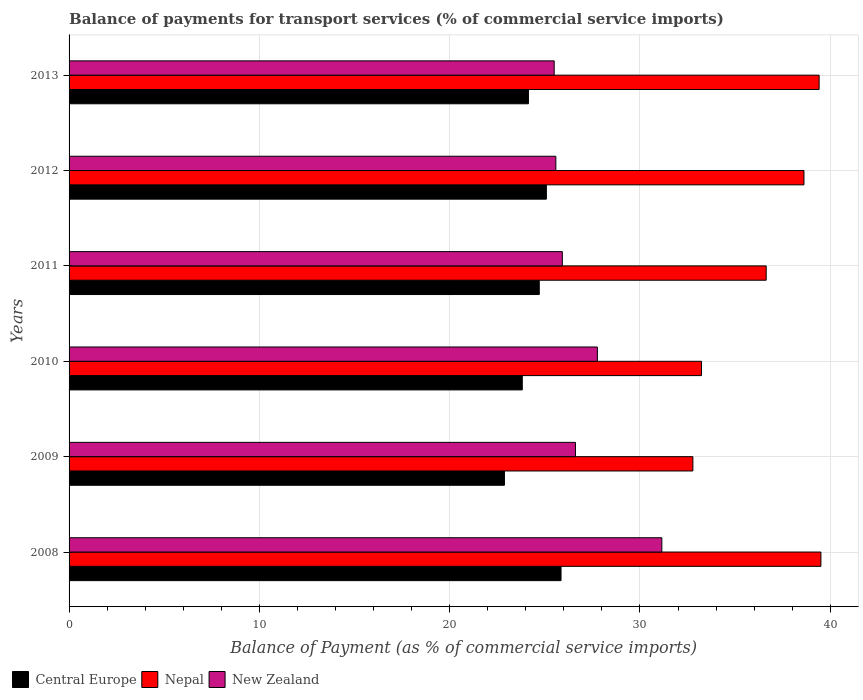How many different coloured bars are there?
Your response must be concise. 3. How many groups of bars are there?
Ensure brevity in your answer.  6. Are the number of bars on each tick of the Y-axis equal?
Keep it short and to the point. Yes. How many bars are there on the 6th tick from the bottom?
Offer a terse response. 3. What is the label of the 3rd group of bars from the top?
Keep it short and to the point. 2011. What is the balance of payments for transport services in Nepal in 2010?
Keep it short and to the point. 33.23. Across all years, what is the maximum balance of payments for transport services in Central Europe?
Your response must be concise. 25.85. Across all years, what is the minimum balance of payments for transport services in New Zealand?
Your answer should be very brief. 25.49. What is the total balance of payments for transport services in Central Europe in the graph?
Ensure brevity in your answer.  146.47. What is the difference between the balance of payments for transport services in Nepal in 2008 and that in 2011?
Provide a short and direct response. 2.88. What is the difference between the balance of payments for transport services in Central Europe in 2010 and the balance of payments for transport services in New Zealand in 2012?
Your answer should be compact. -1.76. What is the average balance of payments for transport services in Nepal per year?
Your answer should be very brief. 36.7. In the year 2013, what is the difference between the balance of payments for transport services in Central Europe and balance of payments for transport services in New Zealand?
Provide a succinct answer. -1.35. What is the ratio of the balance of payments for transport services in Central Europe in 2010 to that in 2012?
Your answer should be compact. 0.95. Is the balance of payments for transport services in New Zealand in 2008 less than that in 2012?
Your answer should be compact. No. What is the difference between the highest and the second highest balance of payments for transport services in Nepal?
Keep it short and to the point. 0.09. What is the difference between the highest and the lowest balance of payments for transport services in Central Europe?
Make the answer very short. 2.97. Is the sum of the balance of payments for transport services in Nepal in 2010 and 2011 greater than the maximum balance of payments for transport services in Central Europe across all years?
Your response must be concise. Yes. What does the 3rd bar from the top in 2011 represents?
Keep it short and to the point. Central Europe. What does the 1st bar from the bottom in 2012 represents?
Provide a short and direct response. Central Europe. How many bars are there?
Give a very brief answer. 18. Are the values on the major ticks of X-axis written in scientific E-notation?
Offer a terse response. No. Does the graph contain grids?
Keep it short and to the point. Yes. Where does the legend appear in the graph?
Provide a short and direct response. Bottom left. How are the legend labels stacked?
Keep it short and to the point. Horizontal. What is the title of the graph?
Your response must be concise. Balance of payments for transport services (% of commercial service imports). Does "Belgium" appear as one of the legend labels in the graph?
Offer a terse response. No. What is the label or title of the X-axis?
Your answer should be compact. Balance of Payment (as % of commercial service imports). What is the label or title of the Y-axis?
Keep it short and to the point. Years. What is the Balance of Payment (as % of commercial service imports) in Central Europe in 2008?
Your answer should be compact. 25.85. What is the Balance of Payment (as % of commercial service imports) of Nepal in 2008?
Provide a succinct answer. 39.51. What is the Balance of Payment (as % of commercial service imports) of New Zealand in 2008?
Give a very brief answer. 31.15. What is the Balance of Payment (as % of commercial service imports) in Central Europe in 2009?
Provide a short and direct response. 22.88. What is the Balance of Payment (as % of commercial service imports) in Nepal in 2009?
Provide a short and direct response. 32.78. What is the Balance of Payment (as % of commercial service imports) in New Zealand in 2009?
Ensure brevity in your answer.  26.61. What is the Balance of Payment (as % of commercial service imports) in Central Europe in 2010?
Provide a succinct answer. 23.82. What is the Balance of Payment (as % of commercial service imports) of Nepal in 2010?
Make the answer very short. 33.23. What is the Balance of Payment (as % of commercial service imports) in New Zealand in 2010?
Your response must be concise. 27.76. What is the Balance of Payment (as % of commercial service imports) in Central Europe in 2011?
Give a very brief answer. 24.71. What is the Balance of Payment (as % of commercial service imports) in Nepal in 2011?
Your answer should be very brief. 36.63. What is the Balance of Payment (as % of commercial service imports) of New Zealand in 2011?
Keep it short and to the point. 25.92. What is the Balance of Payment (as % of commercial service imports) of Central Europe in 2012?
Make the answer very short. 25.08. What is the Balance of Payment (as % of commercial service imports) in Nepal in 2012?
Offer a terse response. 38.62. What is the Balance of Payment (as % of commercial service imports) in New Zealand in 2012?
Provide a succinct answer. 25.58. What is the Balance of Payment (as % of commercial service imports) of Central Europe in 2013?
Offer a very short reply. 24.14. What is the Balance of Payment (as % of commercial service imports) in Nepal in 2013?
Provide a succinct answer. 39.41. What is the Balance of Payment (as % of commercial service imports) in New Zealand in 2013?
Make the answer very short. 25.49. Across all years, what is the maximum Balance of Payment (as % of commercial service imports) in Central Europe?
Your answer should be compact. 25.85. Across all years, what is the maximum Balance of Payment (as % of commercial service imports) in Nepal?
Your answer should be very brief. 39.51. Across all years, what is the maximum Balance of Payment (as % of commercial service imports) in New Zealand?
Provide a short and direct response. 31.15. Across all years, what is the minimum Balance of Payment (as % of commercial service imports) in Central Europe?
Make the answer very short. 22.88. Across all years, what is the minimum Balance of Payment (as % of commercial service imports) in Nepal?
Offer a terse response. 32.78. Across all years, what is the minimum Balance of Payment (as % of commercial service imports) of New Zealand?
Give a very brief answer. 25.49. What is the total Balance of Payment (as % of commercial service imports) in Central Europe in the graph?
Offer a very short reply. 146.47. What is the total Balance of Payment (as % of commercial service imports) in Nepal in the graph?
Provide a short and direct response. 220.18. What is the total Balance of Payment (as % of commercial service imports) in New Zealand in the graph?
Offer a very short reply. 162.51. What is the difference between the Balance of Payment (as % of commercial service imports) of Central Europe in 2008 and that in 2009?
Keep it short and to the point. 2.97. What is the difference between the Balance of Payment (as % of commercial service imports) of Nepal in 2008 and that in 2009?
Provide a succinct answer. 6.73. What is the difference between the Balance of Payment (as % of commercial service imports) in New Zealand in 2008 and that in 2009?
Keep it short and to the point. 4.54. What is the difference between the Balance of Payment (as % of commercial service imports) of Central Europe in 2008 and that in 2010?
Ensure brevity in your answer.  2.04. What is the difference between the Balance of Payment (as % of commercial service imports) in Nepal in 2008 and that in 2010?
Keep it short and to the point. 6.28. What is the difference between the Balance of Payment (as % of commercial service imports) of New Zealand in 2008 and that in 2010?
Make the answer very short. 3.39. What is the difference between the Balance of Payment (as % of commercial service imports) of Central Europe in 2008 and that in 2011?
Offer a terse response. 1.14. What is the difference between the Balance of Payment (as % of commercial service imports) in Nepal in 2008 and that in 2011?
Provide a short and direct response. 2.88. What is the difference between the Balance of Payment (as % of commercial service imports) in New Zealand in 2008 and that in 2011?
Provide a succinct answer. 5.23. What is the difference between the Balance of Payment (as % of commercial service imports) of Central Europe in 2008 and that in 2012?
Offer a terse response. 0.77. What is the difference between the Balance of Payment (as % of commercial service imports) in Nepal in 2008 and that in 2012?
Provide a short and direct response. 0.89. What is the difference between the Balance of Payment (as % of commercial service imports) of New Zealand in 2008 and that in 2012?
Your response must be concise. 5.57. What is the difference between the Balance of Payment (as % of commercial service imports) in Central Europe in 2008 and that in 2013?
Offer a very short reply. 1.71. What is the difference between the Balance of Payment (as % of commercial service imports) in Nepal in 2008 and that in 2013?
Give a very brief answer. 0.09. What is the difference between the Balance of Payment (as % of commercial service imports) of New Zealand in 2008 and that in 2013?
Offer a terse response. 5.66. What is the difference between the Balance of Payment (as % of commercial service imports) in Central Europe in 2009 and that in 2010?
Your answer should be compact. -0.94. What is the difference between the Balance of Payment (as % of commercial service imports) in Nepal in 2009 and that in 2010?
Keep it short and to the point. -0.45. What is the difference between the Balance of Payment (as % of commercial service imports) of New Zealand in 2009 and that in 2010?
Offer a very short reply. -1.15. What is the difference between the Balance of Payment (as % of commercial service imports) in Central Europe in 2009 and that in 2011?
Provide a succinct answer. -1.83. What is the difference between the Balance of Payment (as % of commercial service imports) in Nepal in 2009 and that in 2011?
Your response must be concise. -3.85. What is the difference between the Balance of Payment (as % of commercial service imports) of New Zealand in 2009 and that in 2011?
Keep it short and to the point. 0.69. What is the difference between the Balance of Payment (as % of commercial service imports) of Central Europe in 2009 and that in 2012?
Provide a succinct answer. -2.2. What is the difference between the Balance of Payment (as % of commercial service imports) in Nepal in 2009 and that in 2012?
Give a very brief answer. -5.84. What is the difference between the Balance of Payment (as % of commercial service imports) of New Zealand in 2009 and that in 2012?
Ensure brevity in your answer.  1.03. What is the difference between the Balance of Payment (as % of commercial service imports) of Central Europe in 2009 and that in 2013?
Provide a short and direct response. -1.26. What is the difference between the Balance of Payment (as % of commercial service imports) of Nepal in 2009 and that in 2013?
Keep it short and to the point. -6.63. What is the difference between the Balance of Payment (as % of commercial service imports) in New Zealand in 2009 and that in 2013?
Your response must be concise. 1.12. What is the difference between the Balance of Payment (as % of commercial service imports) of Central Europe in 2010 and that in 2011?
Offer a very short reply. -0.89. What is the difference between the Balance of Payment (as % of commercial service imports) of Nepal in 2010 and that in 2011?
Make the answer very short. -3.4. What is the difference between the Balance of Payment (as % of commercial service imports) of New Zealand in 2010 and that in 2011?
Your answer should be compact. 1.84. What is the difference between the Balance of Payment (as % of commercial service imports) in Central Europe in 2010 and that in 2012?
Your answer should be very brief. -1.27. What is the difference between the Balance of Payment (as % of commercial service imports) in Nepal in 2010 and that in 2012?
Keep it short and to the point. -5.39. What is the difference between the Balance of Payment (as % of commercial service imports) in New Zealand in 2010 and that in 2012?
Give a very brief answer. 2.18. What is the difference between the Balance of Payment (as % of commercial service imports) in Central Europe in 2010 and that in 2013?
Your answer should be compact. -0.32. What is the difference between the Balance of Payment (as % of commercial service imports) of Nepal in 2010 and that in 2013?
Give a very brief answer. -6.18. What is the difference between the Balance of Payment (as % of commercial service imports) in New Zealand in 2010 and that in 2013?
Keep it short and to the point. 2.27. What is the difference between the Balance of Payment (as % of commercial service imports) of Central Europe in 2011 and that in 2012?
Provide a succinct answer. -0.37. What is the difference between the Balance of Payment (as % of commercial service imports) of Nepal in 2011 and that in 2012?
Ensure brevity in your answer.  -1.99. What is the difference between the Balance of Payment (as % of commercial service imports) in New Zealand in 2011 and that in 2012?
Provide a succinct answer. 0.34. What is the difference between the Balance of Payment (as % of commercial service imports) in Central Europe in 2011 and that in 2013?
Provide a succinct answer. 0.57. What is the difference between the Balance of Payment (as % of commercial service imports) of Nepal in 2011 and that in 2013?
Provide a short and direct response. -2.78. What is the difference between the Balance of Payment (as % of commercial service imports) of New Zealand in 2011 and that in 2013?
Make the answer very short. 0.43. What is the difference between the Balance of Payment (as % of commercial service imports) in Central Europe in 2012 and that in 2013?
Make the answer very short. 0.94. What is the difference between the Balance of Payment (as % of commercial service imports) of Nepal in 2012 and that in 2013?
Your answer should be compact. -0.8. What is the difference between the Balance of Payment (as % of commercial service imports) in New Zealand in 2012 and that in 2013?
Give a very brief answer. 0.09. What is the difference between the Balance of Payment (as % of commercial service imports) in Central Europe in 2008 and the Balance of Payment (as % of commercial service imports) in Nepal in 2009?
Ensure brevity in your answer.  -6.93. What is the difference between the Balance of Payment (as % of commercial service imports) of Central Europe in 2008 and the Balance of Payment (as % of commercial service imports) of New Zealand in 2009?
Offer a terse response. -0.76. What is the difference between the Balance of Payment (as % of commercial service imports) of Nepal in 2008 and the Balance of Payment (as % of commercial service imports) of New Zealand in 2009?
Offer a very short reply. 12.9. What is the difference between the Balance of Payment (as % of commercial service imports) of Central Europe in 2008 and the Balance of Payment (as % of commercial service imports) of Nepal in 2010?
Your response must be concise. -7.38. What is the difference between the Balance of Payment (as % of commercial service imports) of Central Europe in 2008 and the Balance of Payment (as % of commercial service imports) of New Zealand in 2010?
Keep it short and to the point. -1.91. What is the difference between the Balance of Payment (as % of commercial service imports) in Nepal in 2008 and the Balance of Payment (as % of commercial service imports) in New Zealand in 2010?
Keep it short and to the point. 11.75. What is the difference between the Balance of Payment (as % of commercial service imports) in Central Europe in 2008 and the Balance of Payment (as % of commercial service imports) in Nepal in 2011?
Ensure brevity in your answer.  -10.78. What is the difference between the Balance of Payment (as % of commercial service imports) in Central Europe in 2008 and the Balance of Payment (as % of commercial service imports) in New Zealand in 2011?
Your response must be concise. -0.07. What is the difference between the Balance of Payment (as % of commercial service imports) of Nepal in 2008 and the Balance of Payment (as % of commercial service imports) of New Zealand in 2011?
Your answer should be compact. 13.59. What is the difference between the Balance of Payment (as % of commercial service imports) of Central Europe in 2008 and the Balance of Payment (as % of commercial service imports) of Nepal in 2012?
Your answer should be very brief. -12.77. What is the difference between the Balance of Payment (as % of commercial service imports) of Central Europe in 2008 and the Balance of Payment (as % of commercial service imports) of New Zealand in 2012?
Offer a very short reply. 0.27. What is the difference between the Balance of Payment (as % of commercial service imports) in Nepal in 2008 and the Balance of Payment (as % of commercial service imports) in New Zealand in 2012?
Give a very brief answer. 13.93. What is the difference between the Balance of Payment (as % of commercial service imports) of Central Europe in 2008 and the Balance of Payment (as % of commercial service imports) of Nepal in 2013?
Your response must be concise. -13.56. What is the difference between the Balance of Payment (as % of commercial service imports) in Central Europe in 2008 and the Balance of Payment (as % of commercial service imports) in New Zealand in 2013?
Offer a very short reply. 0.36. What is the difference between the Balance of Payment (as % of commercial service imports) of Nepal in 2008 and the Balance of Payment (as % of commercial service imports) of New Zealand in 2013?
Give a very brief answer. 14.01. What is the difference between the Balance of Payment (as % of commercial service imports) in Central Europe in 2009 and the Balance of Payment (as % of commercial service imports) in Nepal in 2010?
Make the answer very short. -10.35. What is the difference between the Balance of Payment (as % of commercial service imports) of Central Europe in 2009 and the Balance of Payment (as % of commercial service imports) of New Zealand in 2010?
Make the answer very short. -4.88. What is the difference between the Balance of Payment (as % of commercial service imports) in Nepal in 2009 and the Balance of Payment (as % of commercial service imports) in New Zealand in 2010?
Your response must be concise. 5.02. What is the difference between the Balance of Payment (as % of commercial service imports) in Central Europe in 2009 and the Balance of Payment (as % of commercial service imports) in Nepal in 2011?
Your answer should be very brief. -13.75. What is the difference between the Balance of Payment (as % of commercial service imports) in Central Europe in 2009 and the Balance of Payment (as % of commercial service imports) in New Zealand in 2011?
Provide a short and direct response. -3.04. What is the difference between the Balance of Payment (as % of commercial service imports) of Nepal in 2009 and the Balance of Payment (as % of commercial service imports) of New Zealand in 2011?
Your answer should be compact. 6.86. What is the difference between the Balance of Payment (as % of commercial service imports) in Central Europe in 2009 and the Balance of Payment (as % of commercial service imports) in Nepal in 2012?
Your answer should be very brief. -15.74. What is the difference between the Balance of Payment (as % of commercial service imports) of Central Europe in 2009 and the Balance of Payment (as % of commercial service imports) of New Zealand in 2012?
Provide a succinct answer. -2.7. What is the difference between the Balance of Payment (as % of commercial service imports) of Nepal in 2009 and the Balance of Payment (as % of commercial service imports) of New Zealand in 2012?
Your response must be concise. 7.2. What is the difference between the Balance of Payment (as % of commercial service imports) of Central Europe in 2009 and the Balance of Payment (as % of commercial service imports) of Nepal in 2013?
Your response must be concise. -16.54. What is the difference between the Balance of Payment (as % of commercial service imports) in Central Europe in 2009 and the Balance of Payment (as % of commercial service imports) in New Zealand in 2013?
Provide a succinct answer. -2.61. What is the difference between the Balance of Payment (as % of commercial service imports) in Nepal in 2009 and the Balance of Payment (as % of commercial service imports) in New Zealand in 2013?
Ensure brevity in your answer.  7.29. What is the difference between the Balance of Payment (as % of commercial service imports) in Central Europe in 2010 and the Balance of Payment (as % of commercial service imports) in Nepal in 2011?
Your response must be concise. -12.82. What is the difference between the Balance of Payment (as % of commercial service imports) in Central Europe in 2010 and the Balance of Payment (as % of commercial service imports) in New Zealand in 2011?
Provide a succinct answer. -2.1. What is the difference between the Balance of Payment (as % of commercial service imports) of Nepal in 2010 and the Balance of Payment (as % of commercial service imports) of New Zealand in 2011?
Ensure brevity in your answer.  7.31. What is the difference between the Balance of Payment (as % of commercial service imports) of Central Europe in 2010 and the Balance of Payment (as % of commercial service imports) of Nepal in 2012?
Keep it short and to the point. -14.8. What is the difference between the Balance of Payment (as % of commercial service imports) in Central Europe in 2010 and the Balance of Payment (as % of commercial service imports) in New Zealand in 2012?
Your answer should be compact. -1.76. What is the difference between the Balance of Payment (as % of commercial service imports) in Nepal in 2010 and the Balance of Payment (as % of commercial service imports) in New Zealand in 2012?
Keep it short and to the point. 7.65. What is the difference between the Balance of Payment (as % of commercial service imports) of Central Europe in 2010 and the Balance of Payment (as % of commercial service imports) of Nepal in 2013?
Ensure brevity in your answer.  -15.6. What is the difference between the Balance of Payment (as % of commercial service imports) of Central Europe in 2010 and the Balance of Payment (as % of commercial service imports) of New Zealand in 2013?
Provide a short and direct response. -1.68. What is the difference between the Balance of Payment (as % of commercial service imports) in Nepal in 2010 and the Balance of Payment (as % of commercial service imports) in New Zealand in 2013?
Ensure brevity in your answer.  7.74. What is the difference between the Balance of Payment (as % of commercial service imports) in Central Europe in 2011 and the Balance of Payment (as % of commercial service imports) in Nepal in 2012?
Keep it short and to the point. -13.91. What is the difference between the Balance of Payment (as % of commercial service imports) in Central Europe in 2011 and the Balance of Payment (as % of commercial service imports) in New Zealand in 2012?
Offer a very short reply. -0.87. What is the difference between the Balance of Payment (as % of commercial service imports) in Nepal in 2011 and the Balance of Payment (as % of commercial service imports) in New Zealand in 2012?
Ensure brevity in your answer.  11.05. What is the difference between the Balance of Payment (as % of commercial service imports) in Central Europe in 2011 and the Balance of Payment (as % of commercial service imports) in Nepal in 2013?
Keep it short and to the point. -14.71. What is the difference between the Balance of Payment (as % of commercial service imports) of Central Europe in 2011 and the Balance of Payment (as % of commercial service imports) of New Zealand in 2013?
Your answer should be very brief. -0.78. What is the difference between the Balance of Payment (as % of commercial service imports) in Nepal in 2011 and the Balance of Payment (as % of commercial service imports) in New Zealand in 2013?
Your response must be concise. 11.14. What is the difference between the Balance of Payment (as % of commercial service imports) of Central Europe in 2012 and the Balance of Payment (as % of commercial service imports) of Nepal in 2013?
Ensure brevity in your answer.  -14.33. What is the difference between the Balance of Payment (as % of commercial service imports) of Central Europe in 2012 and the Balance of Payment (as % of commercial service imports) of New Zealand in 2013?
Provide a succinct answer. -0.41. What is the difference between the Balance of Payment (as % of commercial service imports) in Nepal in 2012 and the Balance of Payment (as % of commercial service imports) in New Zealand in 2013?
Provide a short and direct response. 13.12. What is the average Balance of Payment (as % of commercial service imports) in Central Europe per year?
Provide a succinct answer. 24.41. What is the average Balance of Payment (as % of commercial service imports) in Nepal per year?
Provide a succinct answer. 36.7. What is the average Balance of Payment (as % of commercial service imports) in New Zealand per year?
Your response must be concise. 27.08. In the year 2008, what is the difference between the Balance of Payment (as % of commercial service imports) of Central Europe and Balance of Payment (as % of commercial service imports) of Nepal?
Keep it short and to the point. -13.66. In the year 2008, what is the difference between the Balance of Payment (as % of commercial service imports) of Central Europe and Balance of Payment (as % of commercial service imports) of New Zealand?
Ensure brevity in your answer.  -5.3. In the year 2008, what is the difference between the Balance of Payment (as % of commercial service imports) in Nepal and Balance of Payment (as % of commercial service imports) in New Zealand?
Your response must be concise. 8.36. In the year 2009, what is the difference between the Balance of Payment (as % of commercial service imports) in Central Europe and Balance of Payment (as % of commercial service imports) in Nepal?
Give a very brief answer. -9.9. In the year 2009, what is the difference between the Balance of Payment (as % of commercial service imports) in Central Europe and Balance of Payment (as % of commercial service imports) in New Zealand?
Your answer should be compact. -3.73. In the year 2009, what is the difference between the Balance of Payment (as % of commercial service imports) in Nepal and Balance of Payment (as % of commercial service imports) in New Zealand?
Provide a succinct answer. 6.17. In the year 2010, what is the difference between the Balance of Payment (as % of commercial service imports) in Central Europe and Balance of Payment (as % of commercial service imports) in Nepal?
Make the answer very short. -9.42. In the year 2010, what is the difference between the Balance of Payment (as % of commercial service imports) of Central Europe and Balance of Payment (as % of commercial service imports) of New Zealand?
Your response must be concise. -3.95. In the year 2010, what is the difference between the Balance of Payment (as % of commercial service imports) in Nepal and Balance of Payment (as % of commercial service imports) in New Zealand?
Make the answer very short. 5.47. In the year 2011, what is the difference between the Balance of Payment (as % of commercial service imports) in Central Europe and Balance of Payment (as % of commercial service imports) in Nepal?
Provide a short and direct response. -11.92. In the year 2011, what is the difference between the Balance of Payment (as % of commercial service imports) in Central Europe and Balance of Payment (as % of commercial service imports) in New Zealand?
Your answer should be very brief. -1.21. In the year 2011, what is the difference between the Balance of Payment (as % of commercial service imports) of Nepal and Balance of Payment (as % of commercial service imports) of New Zealand?
Your answer should be very brief. 10.71. In the year 2012, what is the difference between the Balance of Payment (as % of commercial service imports) in Central Europe and Balance of Payment (as % of commercial service imports) in Nepal?
Your response must be concise. -13.53. In the year 2012, what is the difference between the Balance of Payment (as % of commercial service imports) in Central Europe and Balance of Payment (as % of commercial service imports) in New Zealand?
Provide a short and direct response. -0.5. In the year 2012, what is the difference between the Balance of Payment (as % of commercial service imports) of Nepal and Balance of Payment (as % of commercial service imports) of New Zealand?
Offer a terse response. 13.04. In the year 2013, what is the difference between the Balance of Payment (as % of commercial service imports) of Central Europe and Balance of Payment (as % of commercial service imports) of Nepal?
Ensure brevity in your answer.  -15.27. In the year 2013, what is the difference between the Balance of Payment (as % of commercial service imports) in Central Europe and Balance of Payment (as % of commercial service imports) in New Zealand?
Make the answer very short. -1.35. In the year 2013, what is the difference between the Balance of Payment (as % of commercial service imports) of Nepal and Balance of Payment (as % of commercial service imports) of New Zealand?
Your answer should be very brief. 13.92. What is the ratio of the Balance of Payment (as % of commercial service imports) in Central Europe in 2008 to that in 2009?
Give a very brief answer. 1.13. What is the ratio of the Balance of Payment (as % of commercial service imports) of Nepal in 2008 to that in 2009?
Offer a very short reply. 1.21. What is the ratio of the Balance of Payment (as % of commercial service imports) in New Zealand in 2008 to that in 2009?
Ensure brevity in your answer.  1.17. What is the ratio of the Balance of Payment (as % of commercial service imports) of Central Europe in 2008 to that in 2010?
Offer a very short reply. 1.09. What is the ratio of the Balance of Payment (as % of commercial service imports) in Nepal in 2008 to that in 2010?
Make the answer very short. 1.19. What is the ratio of the Balance of Payment (as % of commercial service imports) of New Zealand in 2008 to that in 2010?
Offer a terse response. 1.12. What is the ratio of the Balance of Payment (as % of commercial service imports) of Central Europe in 2008 to that in 2011?
Keep it short and to the point. 1.05. What is the ratio of the Balance of Payment (as % of commercial service imports) in Nepal in 2008 to that in 2011?
Ensure brevity in your answer.  1.08. What is the ratio of the Balance of Payment (as % of commercial service imports) in New Zealand in 2008 to that in 2011?
Give a very brief answer. 1.2. What is the ratio of the Balance of Payment (as % of commercial service imports) in Central Europe in 2008 to that in 2012?
Keep it short and to the point. 1.03. What is the ratio of the Balance of Payment (as % of commercial service imports) of Nepal in 2008 to that in 2012?
Your answer should be very brief. 1.02. What is the ratio of the Balance of Payment (as % of commercial service imports) in New Zealand in 2008 to that in 2012?
Offer a terse response. 1.22. What is the ratio of the Balance of Payment (as % of commercial service imports) of Central Europe in 2008 to that in 2013?
Make the answer very short. 1.07. What is the ratio of the Balance of Payment (as % of commercial service imports) in Nepal in 2008 to that in 2013?
Make the answer very short. 1. What is the ratio of the Balance of Payment (as % of commercial service imports) in New Zealand in 2008 to that in 2013?
Offer a very short reply. 1.22. What is the ratio of the Balance of Payment (as % of commercial service imports) of Central Europe in 2009 to that in 2010?
Make the answer very short. 0.96. What is the ratio of the Balance of Payment (as % of commercial service imports) of Nepal in 2009 to that in 2010?
Provide a short and direct response. 0.99. What is the ratio of the Balance of Payment (as % of commercial service imports) of New Zealand in 2009 to that in 2010?
Your answer should be compact. 0.96. What is the ratio of the Balance of Payment (as % of commercial service imports) in Central Europe in 2009 to that in 2011?
Provide a succinct answer. 0.93. What is the ratio of the Balance of Payment (as % of commercial service imports) in Nepal in 2009 to that in 2011?
Provide a succinct answer. 0.89. What is the ratio of the Balance of Payment (as % of commercial service imports) in New Zealand in 2009 to that in 2011?
Make the answer very short. 1.03. What is the ratio of the Balance of Payment (as % of commercial service imports) of Central Europe in 2009 to that in 2012?
Make the answer very short. 0.91. What is the ratio of the Balance of Payment (as % of commercial service imports) of Nepal in 2009 to that in 2012?
Offer a terse response. 0.85. What is the ratio of the Balance of Payment (as % of commercial service imports) of New Zealand in 2009 to that in 2012?
Make the answer very short. 1.04. What is the ratio of the Balance of Payment (as % of commercial service imports) in Central Europe in 2009 to that in 2013?
Give a very brief answer. 0.95. What is the ratio of the Balance of Payment (as % of commercial service imports) in Nepal in 2009 to that in 2013?
Offer a terse response. 0.83. What is the ratio of the Balance of Payment (as % of commercial service imports) in New Zealand in 2009 to that in 2013?
Give a very brief answer. 1.04. What is the ratio of the Balance of Payment (as % of commercial service imports) of Central Europe in 2010 to that in 2011?
Provide a short and direct response. 0.96. What is the ratio of the Balance of Payment (as % of commercial service imports) in Nepal in 2010 to that in 2011?
Make the answer very short. 0.91. What is the ratio of the Balance of Payment (as % of commercial service imports) of New Zealand in 2010 to that in 2011?
Provide a succinct answer. 1.07. What is the ratio of the Balance of Payment (as % of commercial service imports) of Central Europe in 2010 to that in 2012?
Your response must be concise. 0.95. What is the ratio of the Balance of Payment (as % of commercial service imports) in Nepal in 2010 to that in 2012?
Your response must be concise. 0.86. What is the ratio of the Balance of Payment (as % of commercial service imports) of New Zealand in 2010 to that in 2012?
Make the answer very short. 1.09. What is the ratio of the Balance of Payment (as % of commercial service imports) of Central Europe in 2010 to that in 2013?
Your response must be concise. 0.99. What is the ratio of the Balance of Payment (as % of commercial service imports) of Nepal in 2010 to that in 2013?
Make the answer very short. 0.84. What is the ratio of the Balance of Payment (as % of commercial service imports) of New Zealand in 2010 to that in 2013?
Give a very brief answer. 1.09. What is the ratio of the Balance of Payment (as % of commercial service imports) of Central Europe in 2011 to that in 2012?
Your answer should be very brief. 0.99. What is the ratio of the Balance of Payment (as % of commercial service imports) in Nepal in 2011 to that in 2012?
Give a very brief answer. 0.95. What is the ratio of the Balance of Payment (as % of commercial service imports) of New Zealand in 2011 to that in 2012?
Your answer should be very brief. 1.01. What is the ratio of the Balance of Payment (as % of commercial service imports) of Central Europe in 2011 to that in 2013?
Give a very brief answer. 1.02. What is the ratio of the Balance of Payment (as % of commercial service imports) in Nepal in 2011 to that in 2013?
Your answer should be compact. 0.93. What is the ratio of the Balance of Payment (as % of commercial service imports) of New Zealand in 2011 to that in 2013?
Offer a terse response. 1.02. What is the ratio of the Balance of Payment (as % of commercial service imports) in Central Europe in 2012 to that in 2013?
Your answer should be very brief. 1.04. What is the ratio of the Balance of Payment (as % of commercial service imports) in Nepal in 2012 to that in 2013?
Offer a very short reply. 0.98. What is the difference between the highest and the second highest Balance of Payment (as % of commercial service imports) in Central Europe?
Provide a succinct answer. 0.77. What is the difference between the highest and the second highest Balance of Payment (as % of commercial service imports) of Nepal?
Offer a terse response. 0.09. What is the difference between the highest and the second highest Balance of Payment (as % of commercial service imports) of New Zealand?
Provide a short and direct response. 3.39. What is the difference between the highest and the lowest Balance of Payment (as % of commercial service imports) in Central Europe?
Offer a terse response. 2.97. What is the difference between the highest and the lowest Balance of Payment (as % of commercial service imports) of Nepal?
Keep it short and to the point. 6.73. What is the difference between the highest and the lowest Balance of Payment (as % of commercial service imports) of New Zealand?
Make the answer very short. 5.66. 